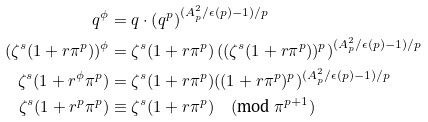Convert formula to latex. <formula><loc_0><loc_0><loc_500><loc_500>q ^ { \phi } & = q \cdot \left ( q ^ { p } \right ) ^ { ( A _ { p } ^ { 2 } / \epsilon ( p ) - 1 ) / p } \\ ( \zeta ^ { s } ( 1 + r \pi ^ { p } ) ) ^ { \phi } & = \zeta ^ { s } ( 1 + r \pi ^ { p } ) \left ( ( \zeta ^ { s } ( 1 + r \pi ^ { p } ) ) ^ { p } \right ) ^ { ( A _ { p } ^ { 2 } / \epsilon ( p ) - 1 ) / p } \\ \zeta ^ { s } ( 1 + r ^ { \phi } \pi ^ { p } ) & = \zeta ^ { s } ( 1 + r \pi ^ { p } ) ( ( 1 + r \pi ^ { p } ) ^ { p } ) ^ { ( A _ { p } ^ { 2 } / \epsilon ( p ) - 1 ) / p } \\ \zeta ^ { s } ( 1 + r ^ { p } \pi ^ { p } ) & \equiv \zeta ^ { s } ( 1 + r \pi ^ { p } ) \quad ( \text {mod} \ \pi ^ { p + 1 } )</formula> 